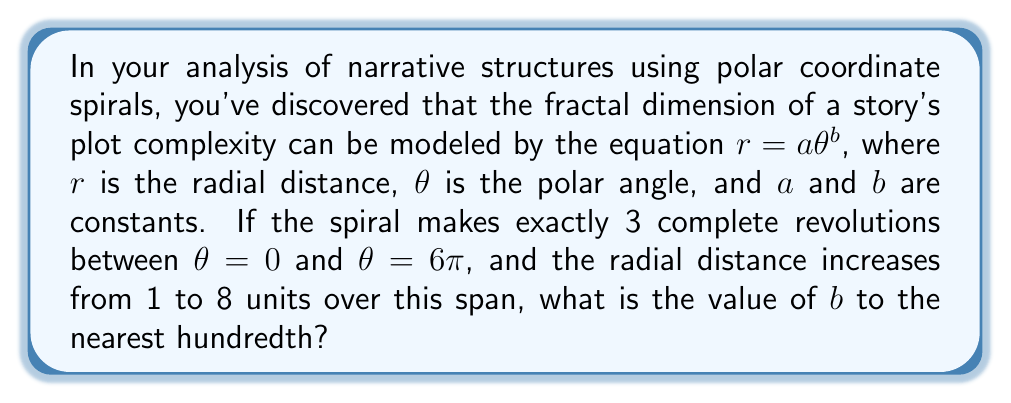Give your solution to this math problem. To solve this problem, we'll follow these steps:

1) We know that the spiral makes 3 complete revolutions between $\theta = 0$ and $\theta = 6\pi$. This doesn't directly affect our calculation, but it confirms that we're using the correct range for $\theta$.

2) We're given that $r = 1$ when $\theta = 0$, and $r = 8$ when $\theta = 6\pi$. We can use these two points to solve for $b$.

3) Let's substitute these values into the equation $r = a\theta^b$:

   For $\theta = 0$: $1 = a(0)^b$ (This is always true for any $b$, so it doesn't help us find $b$)
   For $\theta = 6\pi$: $8 = a(6\pi)^b$

4) We can also write: $1 = a(0^b) = a$

5) Substituting this into the equation from step 3:

   $8 = 1(6\pi)^b$

6) Now we can solve for $b$:

   $8 = (6\pi)^b$
   $\ln(8) = \ln((6\pi)^b)$
   $\ln(8) = b\ln(6\pi)$
   $b = \frac{\ln(8)}{\ln(6\pi)}$

7) Calculate this value:

   $b = \frac{\ln(8)}{\ln(6\pi)} \approx 0.7147$

8) Rounding to the nearest hundredth:

   $b \approx 0.71$
Answer: $b \approx 0.71$ 